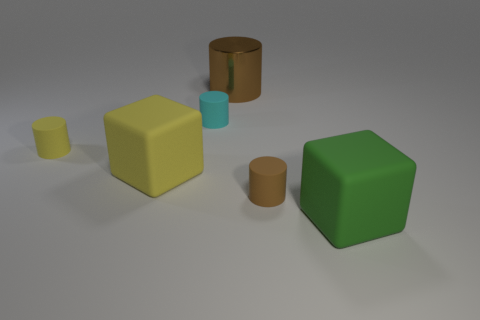What material is the brown thing that is the same size as the cyan rubber cylinder?
Keep it short and to the point. Rubber. Is there a brown object that has the same size as the green matte cube?
Make the answer very short. Yes. The cylinder that is in front of the tiny yellow rubber thing is what color?
Offer a terse response. Brown. There is a large block that is left of the big green thing; are there any tiny cylinders in front of it?
Give a very brief answer. Yes. What number of other things are there of the same color as the metallic cylinder?
Offer a very short reply. 1. Do the block that is right of the cyan rubber object and the brown cylinder that is in front of the cyan cylinder have the same size?
Keep it short and to the point. No. There is a yellow cylinder behind the small matte cylinder that is in front of the yellow cylinder; what is its size?
Offer a very short reply. Small. There is a small object that is in front of the tiny cyan matte thing and to the left of the large cylinder; what material is it made of?
Give a very brief answer. Rubber. What is the color of the large cylinder?
Offer a terse response. Brown. Is there anything else that has the same material as the big cylinder?
Give a very brief answer. No. 